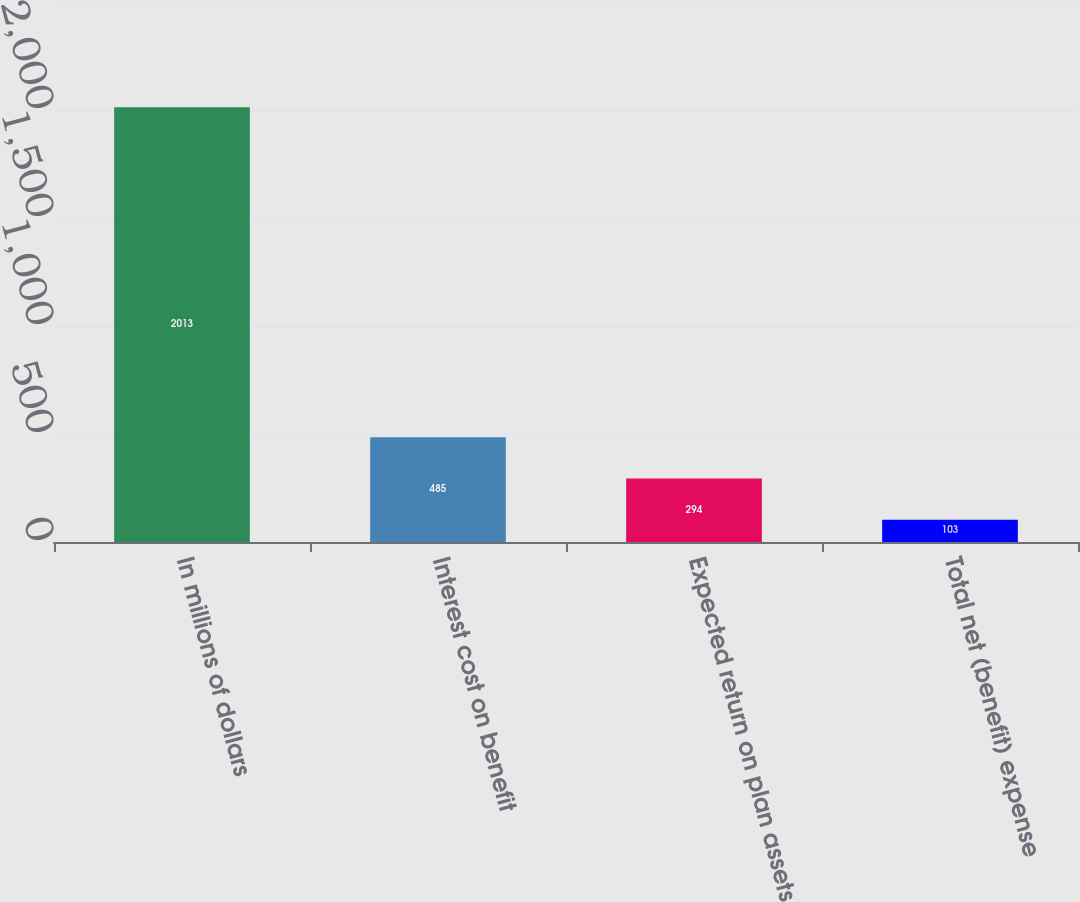Convert chart to OTSL. <chart><loc_0><loc_0><loc_500><loc_500><bar_chart><fcel>In millions of dollars<fcel>Interest cost on benefit<fcel>Expected return on plan assets<fcel>Total net (benefit) expense<nl><fcel>2013<fcel>485<fcel>294<fcel>103<nl></chart> 